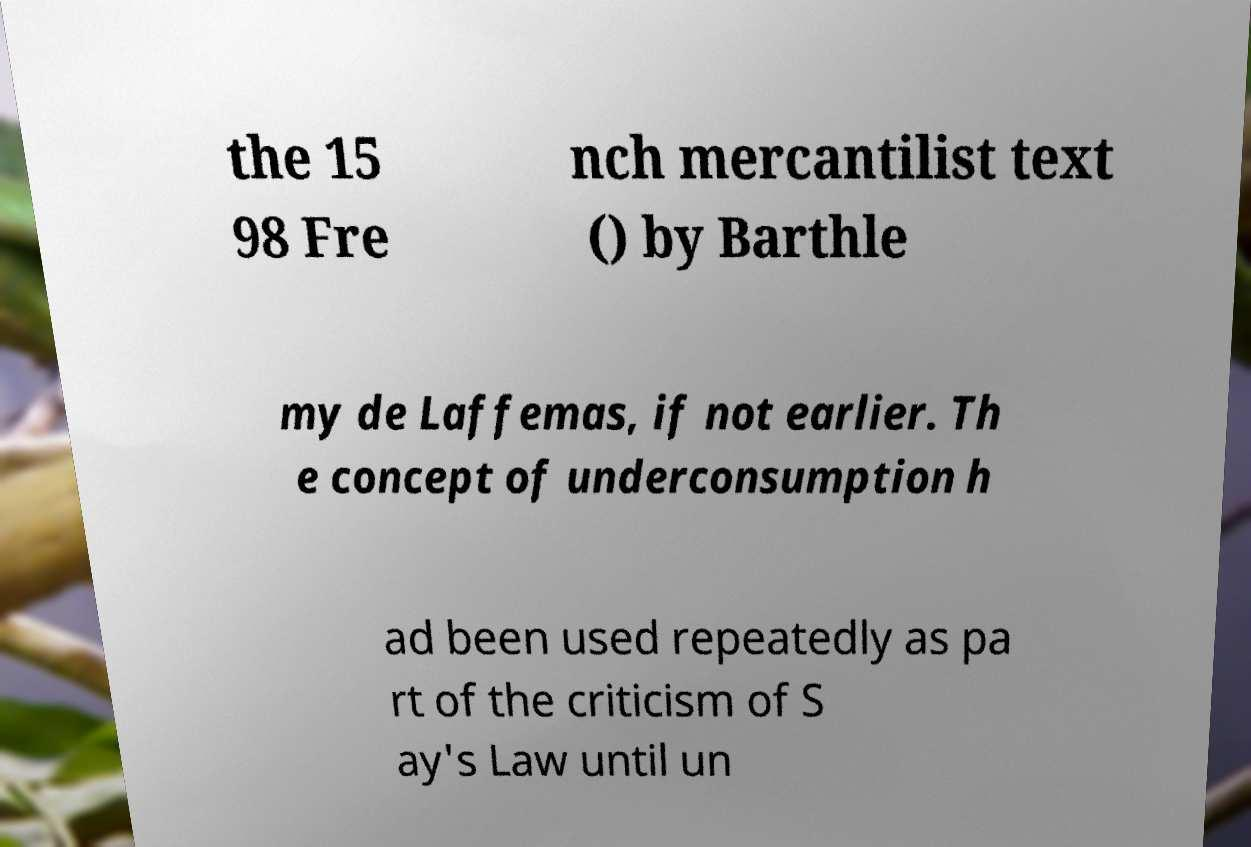Can you accurately transcribe the text from the provided image for me? the 15 98 Fre nch mercantilist text () by Barthle my de Laffemas, if not earlier. Th e concept of underconsumption h ad been used repeatedly as pa rt of the criticism of S ay's Law until un 